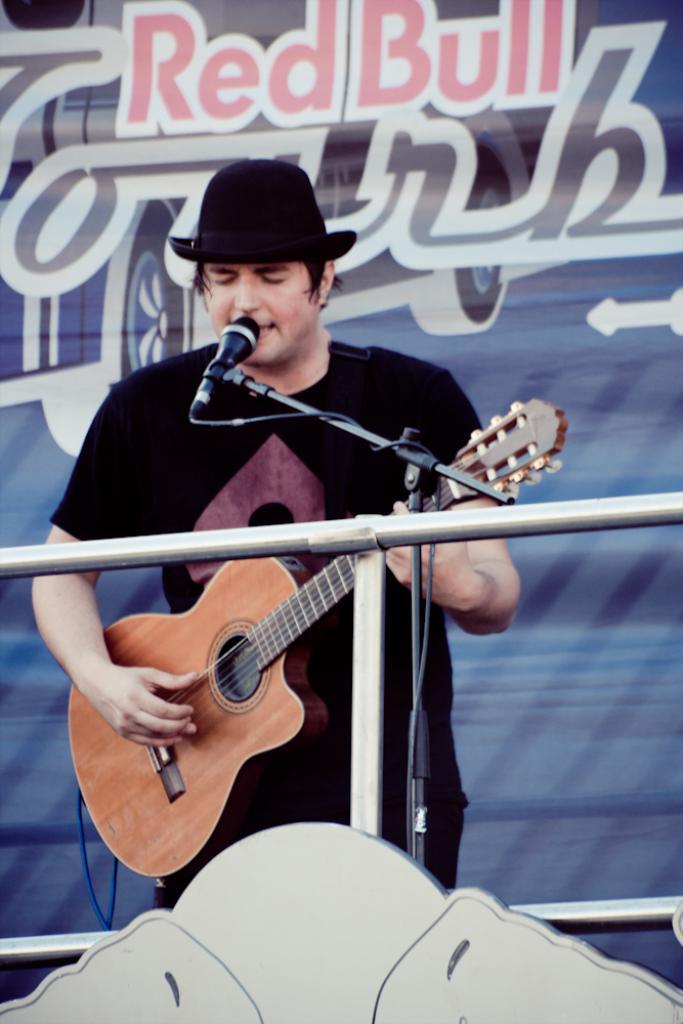How would you summarize this image in a sentence or two? In this picture there is a man who is playing the guitar and singing 